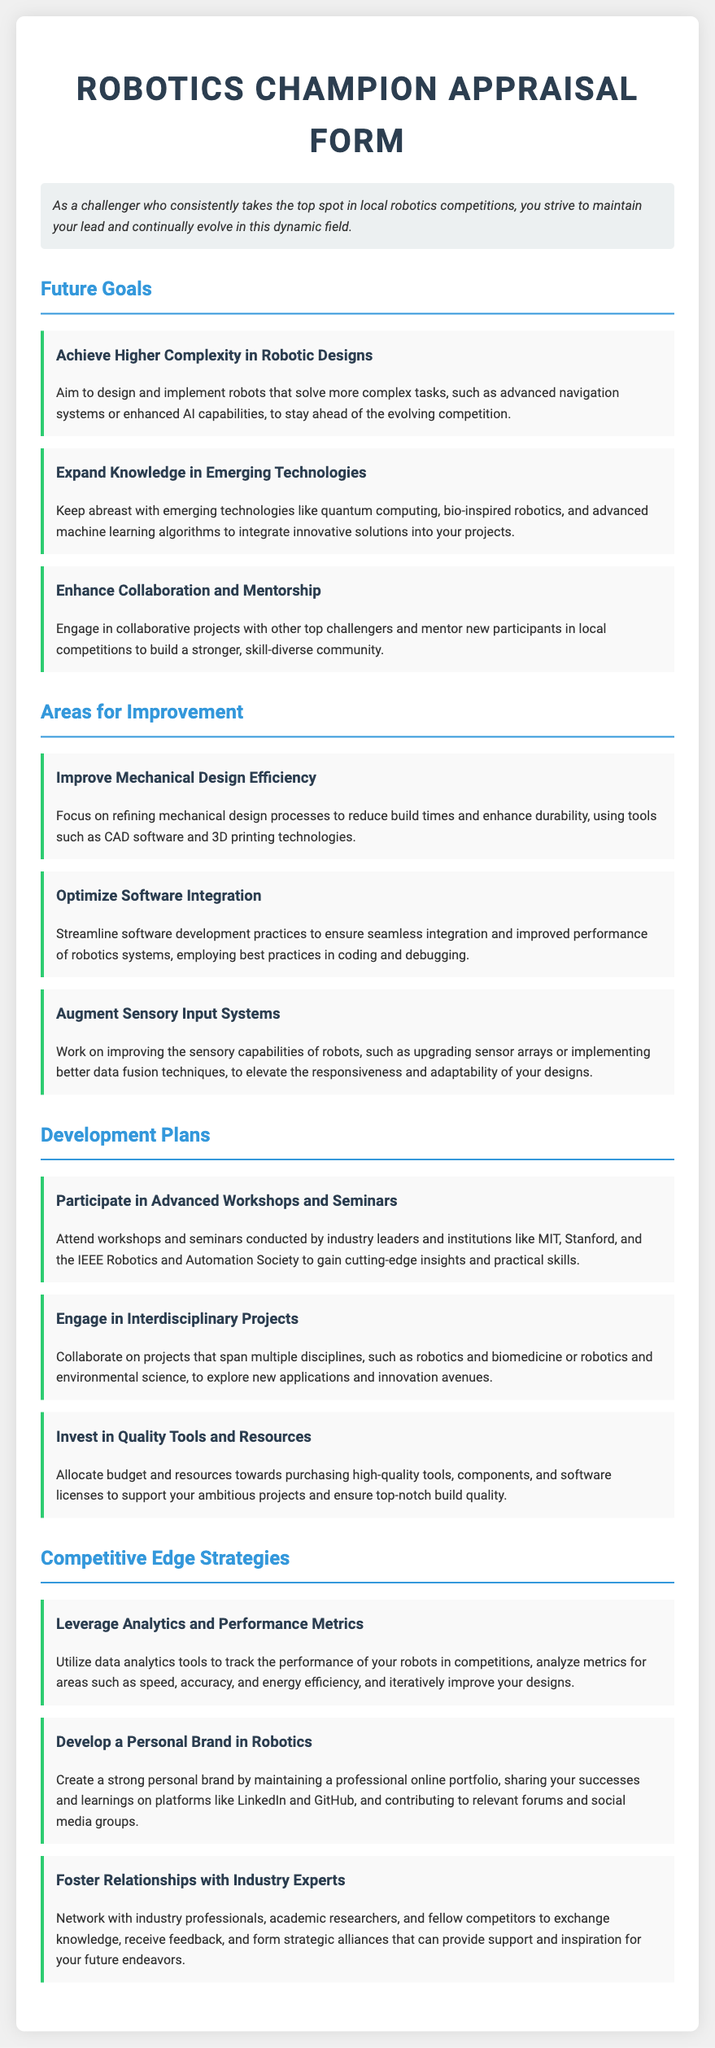what is the title of the document? The title is prominently displayed at the top of the document to define the content's focus.
Answer: Robotics Champion Appraisal Form how many future goals are listed? The document includes a section detailing future goals, highlighting individual aims for skill development and achievements.
Answer: Three what area for improvement focuses on software? The area for improvement section describes various aspects needing enhancement, including technologies relevant to software efficiency.
Answer: Optimize Software Integration name one strategy for maintaining a competitive edge. The competitive edge section discusses various tactics to enhance performance in competitions, providing several strategic options.
Answer: Leverage Analytics and Performance Metrics which institution is mentioned for advanced workshops? Specific organizations known for their contributions to robotics education and research are referenced as key resources for learning.
Answer: MIT 